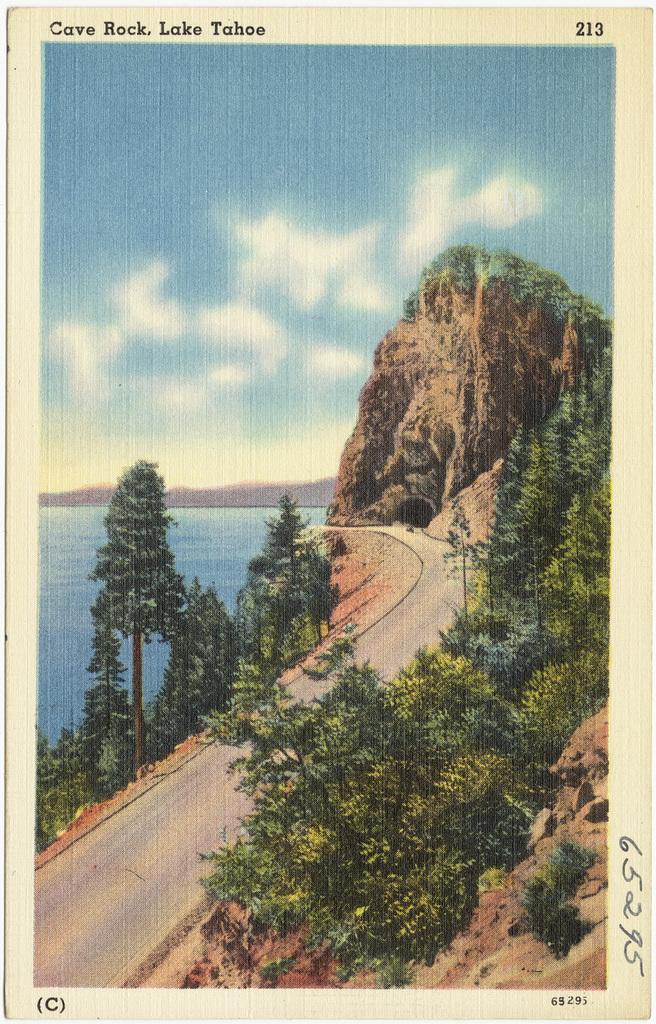What is the main subject of the image? The main subject of the image is a photo. What elements can be seen in the photo? The photo contains trees, mountains, a river, and a road. Are there any fairies visible in the photo? There are no fairies present in the photo; it contains trees, mountains, a river, and a road. What type of crayon is used to draw the photo? The facts do not mention any crayons being used to create the photo, so it cannot be determined from the information provided. 